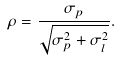Convert formula to latex. <formula><loc_0><loc_0><loc_500><loc_500>\rho = \frac { \sigma _ { p } } { \sqrt { \sigma _ { p } ^ { 2 } + \sigma _ { l } ^ { 2 } } } .</formula> 